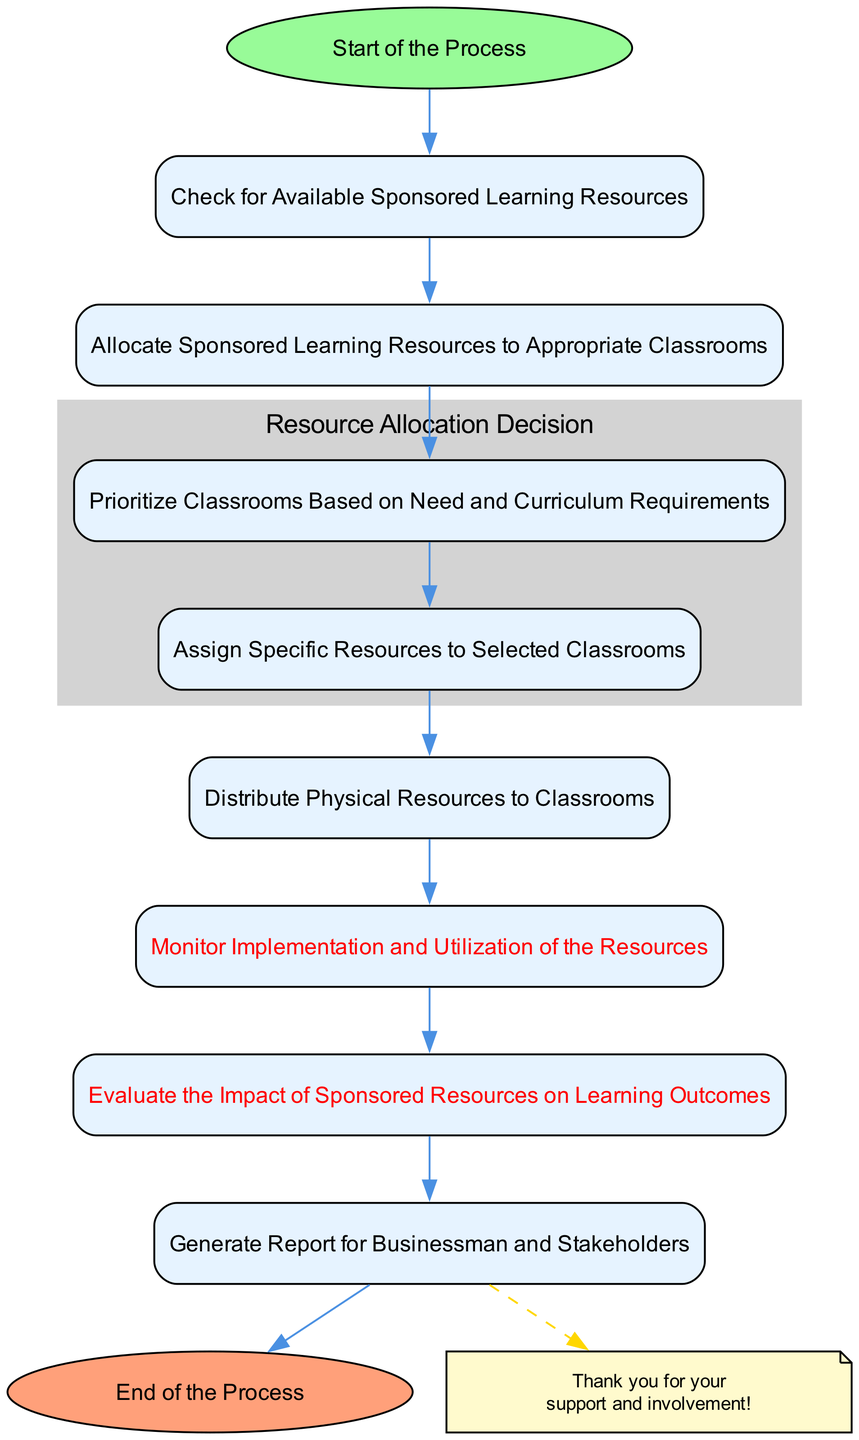What is the first step in the process? The first step is labeled "Start of the Process." It's the initial node in the flowchart from which all activities proceed.
Answer: Start of the Process How many nodes are there in the diagram? By counting all the unique steps outlined in the data provided, we can see there are 10 nodes representing various stages of managing sponsored learning resources.
Answer: 10 Which node comes immediately after "Allocate Sponsored Learning Resources to Appropriate Classrooms"? "Prioritize Classrooms Based on Need and Curriculum Requirements" directly follows the allocation node as the next step in the sequence.
Answer: Prioritize Classrooms Based on Need and Curriculum Requirements What are the two steps emphasized in red? The steps are "Monitor Implementation and Utilization of the Resources" and "Evaluate the Impact of Sponsored Resources on Learning Outcomes." These steps indicate crucial evaluation phases in the process.
Answer: Monitor Implementation and Utilization of the Resources and Evaluate the Impact of Sponsored Resources on Learning Outcomes What is the final action taken in this flowchart? "Generate Report for Businessman and Stakeholders" is the last action, leading directly to the concluding node of the diagram.
Answer: Generate Report for Businessman and Stakeholders What shape is used for the "Start" and "End" nodes? Both "Start" and "End" nodes are formatted as ovals, distinguishing them from the rectangular nodes representing other actions in the process.
Answer: Oval Which step involves distributing physical resources? The step is labeled "Distribute Physical Resources to Classrooms," clearly indicating the action taken to deliver resources.
Answer: Distribute Physical Resources to Classrooms What colors represent the nodes with specific emphasis in the flowchart? The "Start" node is green (light green), the "End" node is salmon (light coral), while crucial evaluation steps are highlighted in red, indicating their importance.
Answer: Light green, light coral, red 